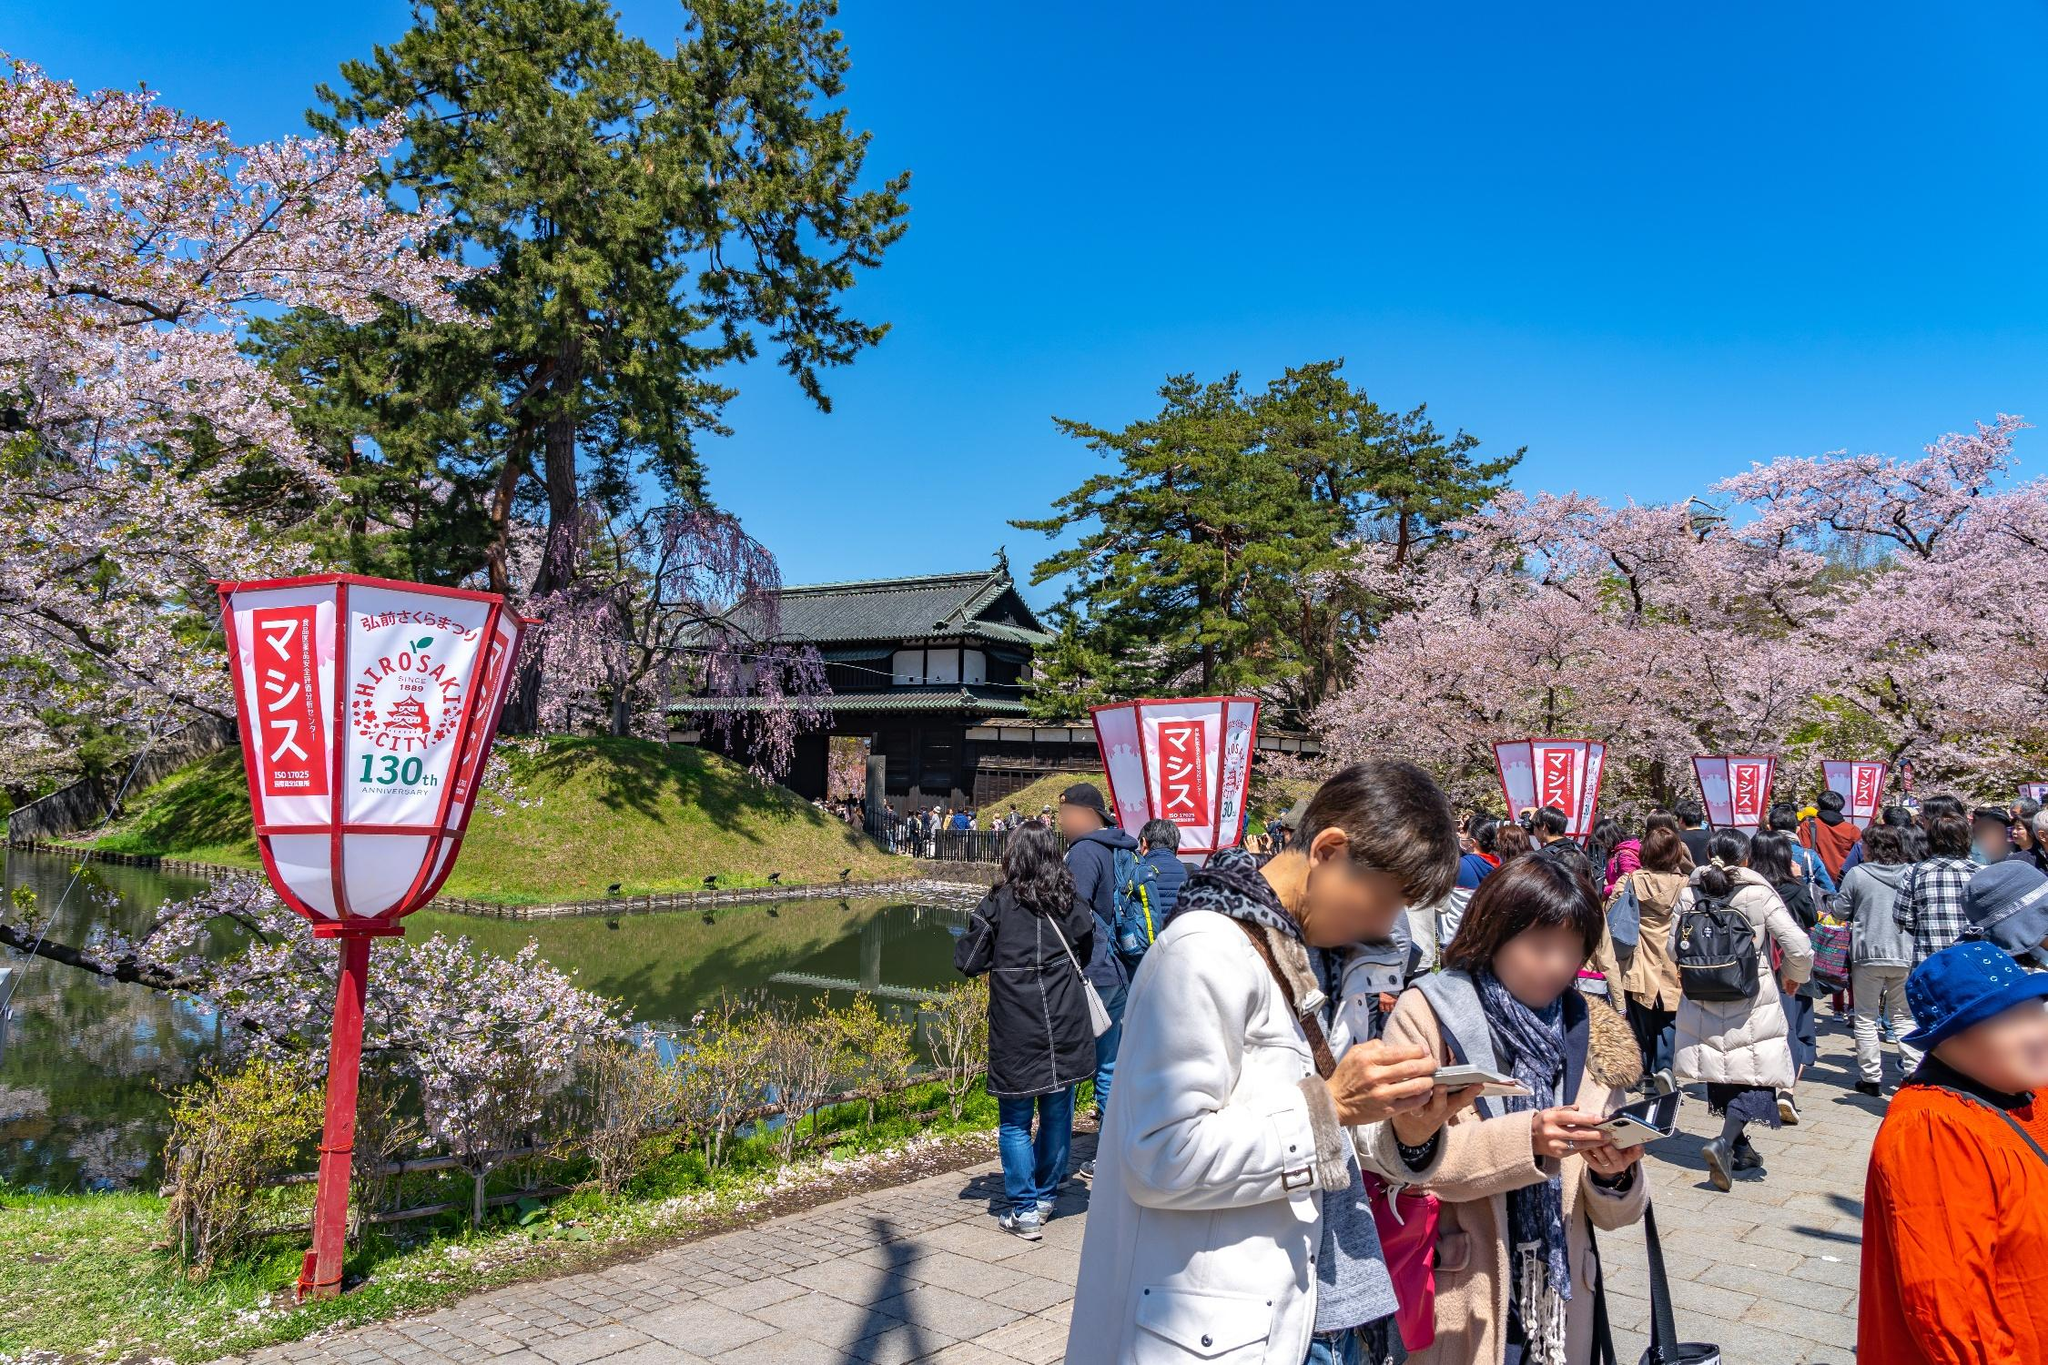What emotions do you think people are experiencing at this festival? At the Hirosaki Castle cherry blossom festival, the predominant emotions are likely joy, wonder, and a sense of peace. The stunning beauty of the cherry blossoms in full bloom, coupled with the historic and cultural backdrop of the castle, creates a euphoric and magical atmosphere. Some individuals might feel nostalgia, especially those who have attended this festival in previous years. Others may feel a profound connection to nature and Japanese cultural heritage, appreciating the festive yet serene ambiance. Overall, the blend of visual splendor and cultural richness fosters a mood of celebration and deep appreciation. 